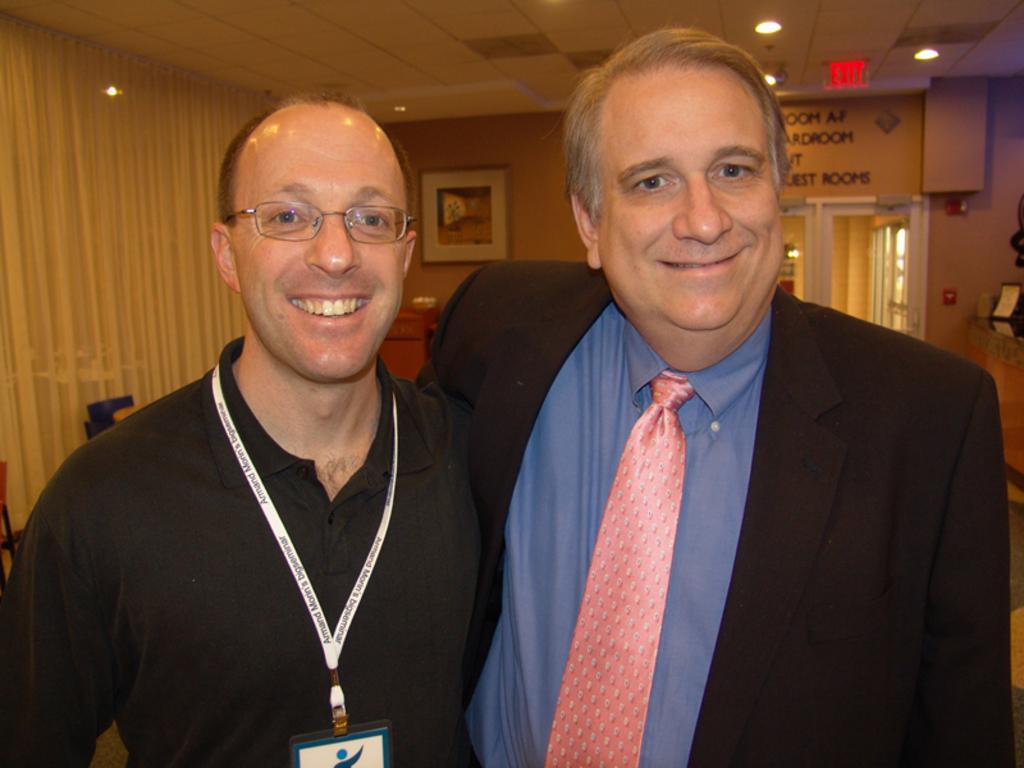Please provide a concise description of this image. In this image we can see two men. And we can see one man wearing spectacles and identity card. And one man wearing tie. And we can see curtains. And we can see the ceiling. And we can see the lights. And behind them we can some object on the wall. And in the top right corner we can see some object. And we can see the door. And we can see the text written on board above the door. 